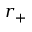Convert formula to latex. <formula><loc_0><loc_0><loc_500><loc_500>r _ { + }</formula> 